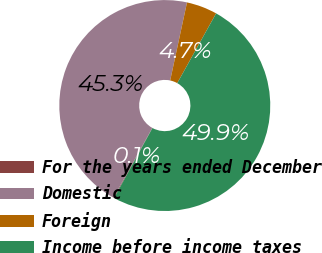<chart> <loc_0><loc_0><loc_500><loc_500><pie_chart><fcel>For the years ended December<fcel>Domestic<fcel>Foreign<fcel>Income before income taxes<nl><fcel>0.11%<fcel>45.29%<fcel>4.71%<fcel>49.89%<nl></chart> 